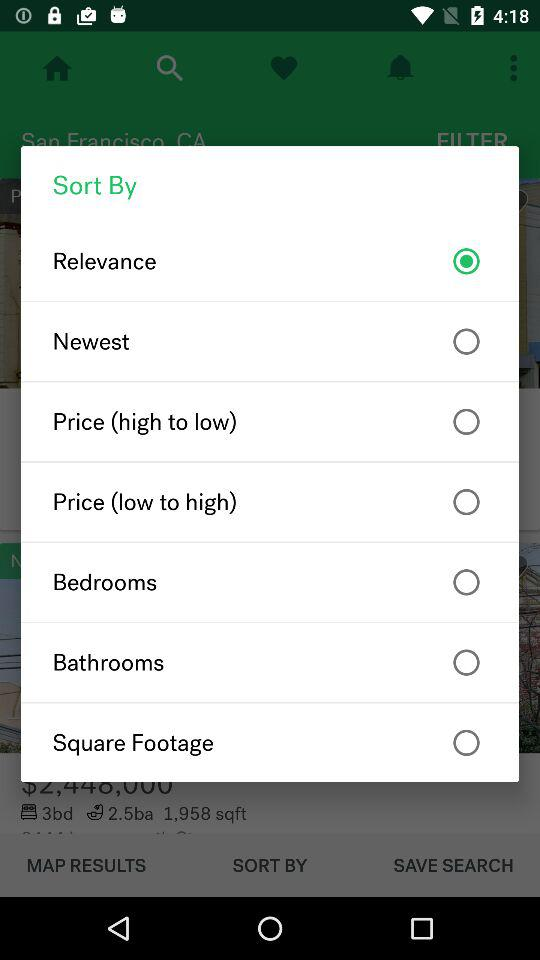What is the selected option? The selected option is "Relevance". 